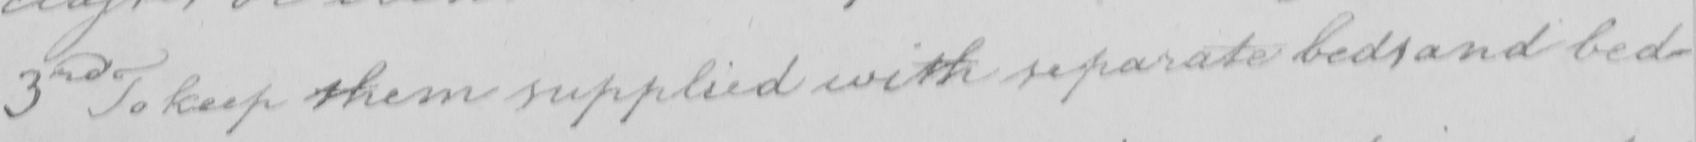What is written in this line of handwriting? 3rd To keep them supplied with separate beds and bed- 